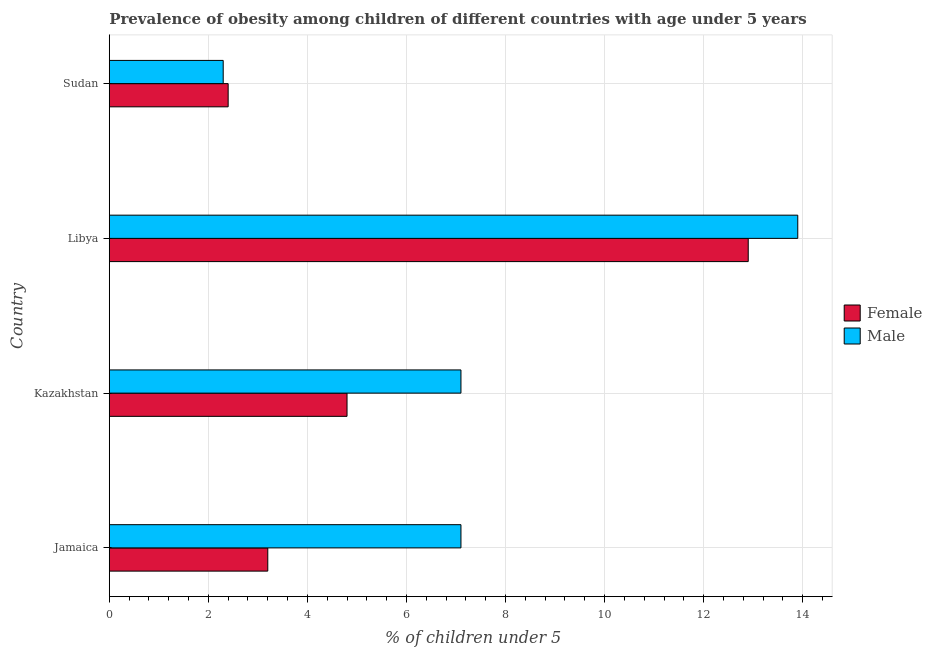How many different coloured bars are there?
Give a very brief answer. 2. How many groups of bars are there?
Your answer should be very brief. 4. Are the number of bars per tick equal to the number of legend labels?
Make the answer very short. Yes. Are the number of bars on each tick of the Y-axis equal?
Offer a terse response. Yes. How many bars are there on the 1st tick from the top?
Give a very brief answer. 2. What is the label of the 3rd group of bars from the top?
Make the answer very short. Kazakhstan. What is the percentage of obese male children in Jamaica?
Provide a succinct answer. 7.1. Across all countries, what is the maximum percentage of obese female children?
Give a very brief answer. 12.9. Across all countries, what is the minimum percentage of obese female children?
Provide a succinct answer. 2.4. In which country was the percentage of obese female children maximum?
Your response must be concise. Libya. In which country was the percentage of obese male children minimum?
Your response must be concise. Sudan. What is the total percentage of obese female children in the graph?
Make the answer very short. 23.3. What is the difference between the percentage of obese male children in Libya and the percentage of obese female children in Kazakhstan?
Keep it short and to the point. 9.1. What is the average percentage of obese male children per country?
Your answer should be very brief. 7.6. What is the difference between the percentage of obese female children and percentage of obese male children in Libya?
Provide a short and direct response. -1. In how many countries, is the percentage of obese female children greater than 12.4 %?
Your answer should be compact. 1. What is the ratio of the percentage of obese male children in Jamaica to that in Sudan?
Ensure brevity in your answer.  3.09. Is the percentage of obese male children in Libya less than that in Sudan?
Your answer should be very brief. No. Is the sum of the percentage of obese female children in Jamaica and Sudan greater than the maximum percentage of obese male children across all countries?
Provide a succinct answer. No. What does the 2nd bar from the top in Libya represents?
Give a very brief answer. Female. What does the 2nd bar from the bottom in Jamaica represents?
Offer a terse response. Male. How many bars are there?
Make the answer very short. 8. Does the graph contain any zero values?
Offer a very short reply. No. How many legend labels are there?
Provide a short and direct response. 2. How are the legend labels stacked?
Provide a short and direct response. Vertical. What is the title of the graph?
Provide a short and direct response. Prevalence of obesity among children of different countries with age under 5 years. What is the label or title of the X-axis?
Provide a succinct answer.  % of children under 5. What is the  % of children under 5 in Female in Jamaica?
Your answer should be very brief. 3.2. What is the  % of children under 5 of Male in Jamaica?
Your answer should be compact. 7.1. What is the  % of children under 5 of Female in Kazakhstan?
Make the answer very short. 4.8. What is the  % of children under 5 in Male in Kazakhstan?
Give a very brief answer. 7.1. What is the  % of children under 5 of Female in Libya?
Offer a very short reply. 12.9. What is the  % of children under 5 in Male in Libya?
Keep it short and to the point. 13.9. What is the  % of children under 5 of Female in Sudan?
Make the answer very short. 2.4. What is the  % of children under 5 of Male in Sudan?
Your response must be concise. 2.3. Across all countries, what is the maximum  % of children under 5 in Female?
Keep it short and to the point. 12.9. Across all countries, what is the maximum  % of children under 5 in Male?
Provide a succinct answer. 13.9. Across all countries, what is the minimum  % of children under 5 in Female?
Offer a terse response. 2.4. Across all countries, what is the minimum  % of children under 5 of Male?
Your answer should be compact. 2.3. What is the total  % of children under 5 of Female in the graph?
Provide a short and direct response. 23.3. What is the total  % of children under 5 of Male in the graph?
Offer a terse response. 30.4. What is the difference between the  % of children under 5 in Female in Jamaica and that in Kazakhstan?
Your answer should be very brief. -1.6. What is the difference between the  % of children under 5 in Female in Jamaica and that in Libya?
Keep it short and to the point. -9.7. What is the difference between the  % of children under 5 in Female in Jamaica and that in Sudan?
Offer a very short reply. 0.8. What is the difference between the  % of children under 5 of Male in Jamaica and that in Sudan?
Keep it short and to the point. 4.8. What is the difference between the  % of children under 5 in Male in Kazakhstan and that in Libya?
Your answer should be very brief. -6.8. What is the difference between the  % of children under 5 of Male in Kazakhstan and that in Sudan?
Your answer should be compact. 4.8. What is the difference between the  % of children under 5 in Female in Libya and that in Sudan?
Give a very brief answer. 10.5. What is the difference between the  % of children under 5 of Female in Kazakhstan and the  % of children under 5 of Male in Sudan?
Your response must be concise. 2.5. What is the average  % of children under 5 of Female per country?
Provide a succinct answer. 5.83. What is the difference between the  % of children under 5 of Female and  % of children under 5 of Male in Jamaica?
Offer a very short reply. -3.9. What is the difference between the  % of children under 5 of Female and  % of children under 5 of Male in Kazakhstan?
Offer a very short reply. -2.3. What is the difference between the  % of children under 5 of Female and  % of children under 5 of Male in Sudan?
Ensure brevity in your answer.  0.1. What is the ratio of the  % of children under 5 in Female in Jamaica to that in Kazakhstan?
Make the answer very short. 0.67. What is the ratio of the  % of children under 5 in Male in Jamaica to that in Kazakhstan?
Keep it short and to the point. 1. What is the ratio of the  % of children under 5 in Female in Jamaica to that in Libya?
Ensure brevity in your answer.  0.25. What is the ratio of the  % of children under 5 in Male in Jamaica to that in Libya?
Offer a terse response. 0.51. What is the ratio of the  % of children under 5 of Male in Jamaica to that in Sudan?
Provide a succinct answer. 3.09. What is the ratio of the  % of children under 5 in Female in Kazakhstan to that in Libya?
Provide a succinct answer. 0.37. What is the ratio of the  % of children under 5 in Male in Kazakhstan to that in Libya?
Provide a succinct answer. 0.51. What is the ratio of the  % of children under 5 of Female in Kazakhstan to that in Sudan?
Your answer should be very brief. 2. What is the ratio of the  % of children under 5 in Male in Kazakhstan to that in Sudan?
Your answer should be compact. 3.09. What is the ratio of the  % of children under 5 in Female in Libya to that in Sudan?
Provide a short and direct response. 5.38. What is the ratio of the  % of children under 5 in Male in Libya to that in Sudan?
Your answer should be compact. 6.04. What is the difference between the highest and the lowest  % of children under 5 of Female?
Your response must be concise. 10.5. What is the difference between the highest and the lowest  % of children under 5 in Male?
Give a very brief answer. 11.6. 